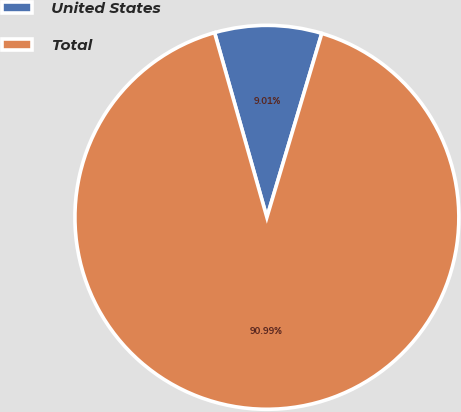Convert chart to OTSL. <chart><loc_0><loc_0><loc_500><loc_500><pie_chart><fcel>United States<fcel>Total<nl><fcel>9.01%<fcel>90.99%<nl></chart> 